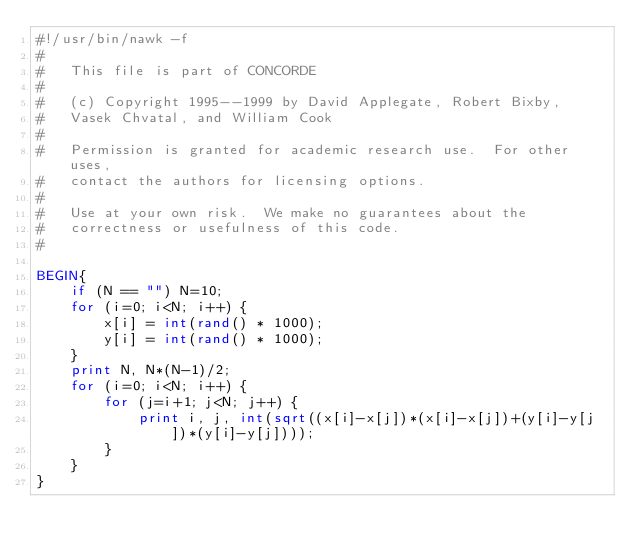Convert code to text. <code><loc_0><loc_0><loc_500><loc_500><_Awk_>#!/usr/bin/nawk -f
#
#   This file is part of CONCORDE
#
#   (c) Copyright 1995--1999 by David Applegate, Robert Bixby,
#   Vasek Chvatal, and William Cook
#
#   Permission is granted for academic research use.  For other uses,
#   contact the authors for licensing options.
#
#   Use at your own risk.  We make no guarantees about the
#   correctness or usefulness of this code.
#

BEGIN{
    if (N == "") N=10;
    for (i=0; i<N; i++) {
        x[i] = int(rand() * 1000);
        y[i] = int(rand() * 1000);
    }
    print N, N*(N-1)/2;
    for (i=0; i<N; i++) {
        for (j=i+1; j<N; j++) {
            print i, j, int(sqrt((x[i]-x[j])*(x[i]-x[j])+(y[i]-y[j])*(y[i]-y[j])));
        }
    }
}

    
</code> 